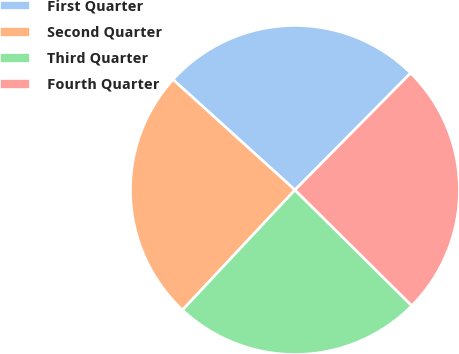<chart> <loc_0><loc_0><loc_500><loc_500><pie_chart><fcel>First Quarter<fcel>Second Quarter<fcel>Third Quarter<fcel>Fourth Quarter<nl><fcel>25.71%<fcel>24.73%<fcel>24.56%<fcel>25.0%<nl></chart> 